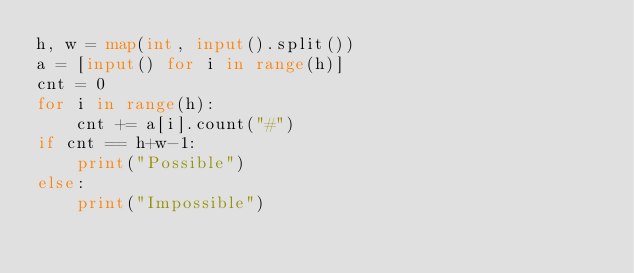<code> <loc_0><loc_0><loc_500><loc_500><_Python_>h, w = map(int, input().split())
a = [input() for i in range(h)]
cnt = 0
for i in range(h):
    cnt += a[i].count("#")
if cnt == h+w-1:
    print("Possible")
else:
    print("Impossible")</code> 